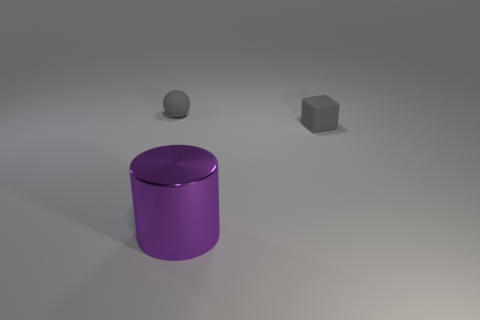There is a tiny gray object that is to the right of the matte object left of the gray matte thing on the right side of the purple metal cylinder; what is it made of?
Your answer should be very brief. Rubber. What number of other objects are the same color as the tiny sphere?
Offer a very short reply. 1. How many purple objects are either blocks or metallic cylinders?
Your answer should be very brief. 1. What material is the gray cube behind the metallic cylinder?
Make the answer very short. Rubber. Is the tiny thing that is to the left of the purple object made of the same material as the purple cylinder?
Ensure brevity in your answer.  No. What is the shape of the purple thing?
Give a very brief answer. Cylinder. There is a gray matte thing to the right of the rubber object that is to the left of the tiny gray cube; what number of blocks are in front of it?
Ensure brevity in your answer.  0. How many other things are made of the same material as the small gray cube?
Offer a terse response. 1. There is a gray block that is the same size as the gray matte sphere; what is its material?
Offer a very short reply. Rubber. There is a large shiny cylinder in front of the tiny block; is it the same color as the matte object left of the small gray matte block?
Provide a succinct answer. No. 